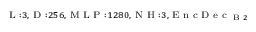Convert formula to latex. <formula><loc_0><loc_0><loc_500><loc_500>_ { L \colon 3 , D \colon 2 5 6 , M L P \colon 1 2 8 0 , N H \colon 3 , E n c D e c _ { B 2 } }</formula> 